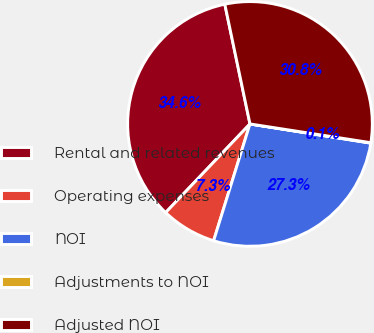<chart> <loc_0><loc_0><loc_500><loc_500><pie_chart><fcel>Rental and related revenues<fcel>Operating expenses<fcel>NOI<fcel>Adjustments to NOI<fcel>Adjusted NOI<nl><fcel>34.6%<fcel>7.3%<fcel>27.29%<fcel>0.06%<fcel>30.75%<nl></chart> 